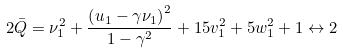Convert formula to latex. <formula><loc_0><loc_0><loc_500><loc_500>2 \bar { Q } = \nu _ { 1 } ^ { 2 } + \frac { \left ( u _ { 1 } - \gamma \nu _ { 1 } \right ) ^ { 2 } } { 1 - \gamma ^ { 2 } } + 1 5 v _ { 1 } ^ { 2 } + 5 w _ { 1 } ^ { 2 } + 1 \leftrightarrow 2</formula> 